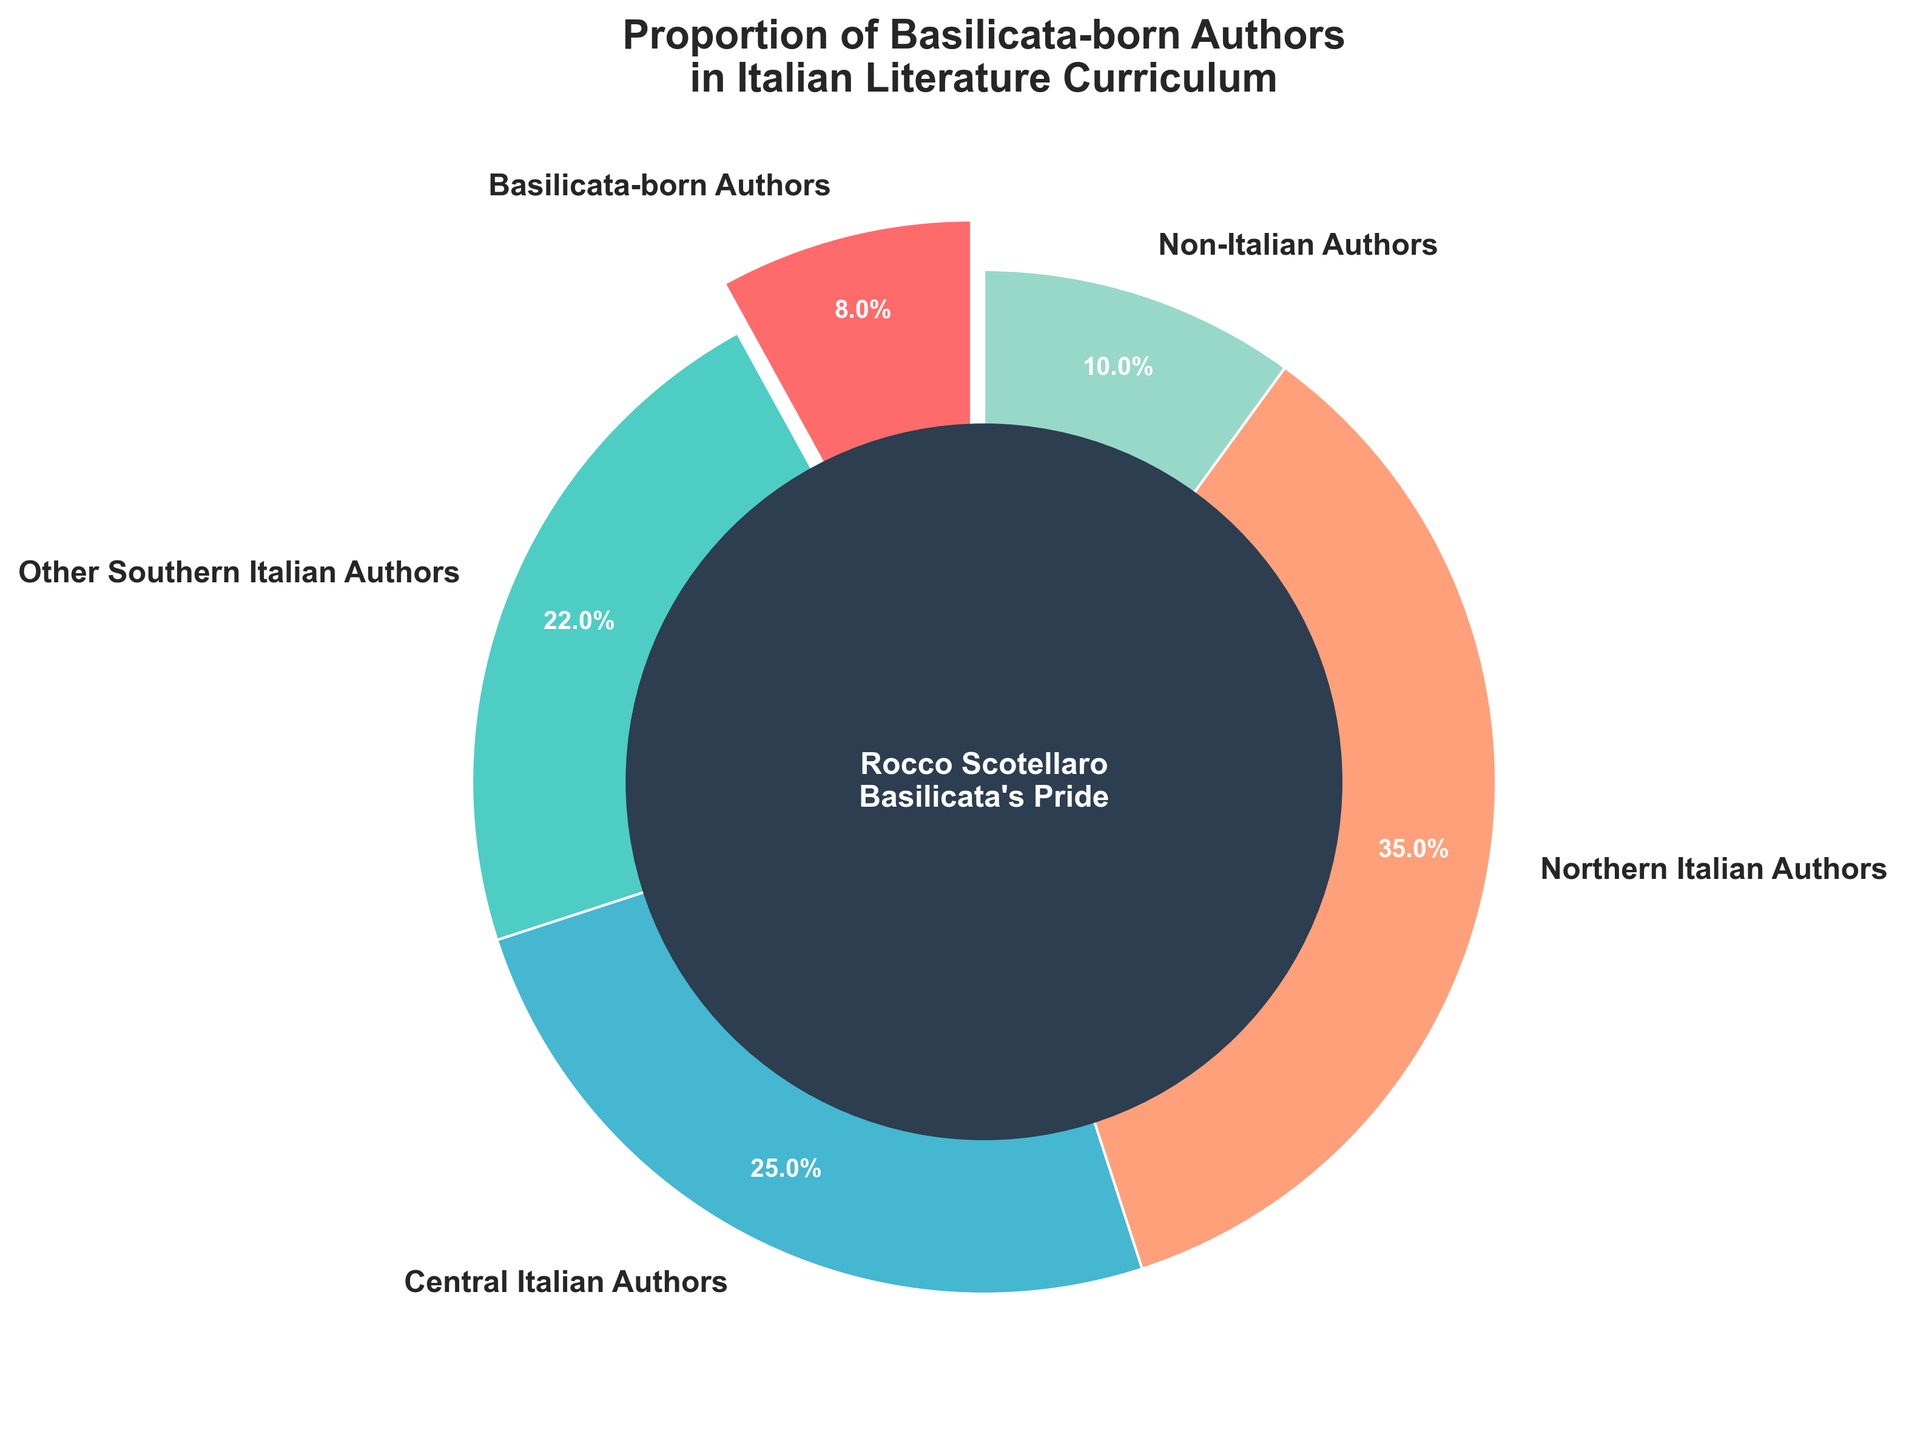How many author categories are represented in the pie chart? The pie chart has separate wedges for each author category. Counting each labeled wedge, we identify five distinct categories: Basilicata-born Authors, Other Southern Italian Authors, Central Italian Authors, Northern Italian Authors, and Non-Italian Authors.
Answer: 5 What percentage of authors are from Northern Italy? Locate the wedge labeled "Northern Italian Authors," and check its associated percentage. The pie chart shows that Northern Italian Authors represent 35% of the total.
Answer: 35% Which category has the smallest representation in the curriculum? Compare the percentages shown for each category in the pie chart. The smallest percentage is associated with Basilicata-born Authors at 8%.
Answer: Basilicata-born Authors How much larger is the percentage of Northern Italian Authors compared to Basilicata-born Authors? Subtract the percentage associated with Basilicata-born Authors from that of Northern Italian Authors, which is 35% - 8%.
Answer: 27% What is the combined percentage of Southern Italian Authors (Basilicata-born and Other Southern Italian Authors)? Add the percentages of Basilicata-born Authors (8%) and Other Southern Italian Authors (22%) together: 8% + 22%.
Answer: 30% By how much do Northern Italian Authors exceed Non-Italian Authors in percentage representation? Subtract the percentage of Non-Italian Authors from that of Northern Italian Authors: 35% - 10%.
Answer: 25% Which category occupies the center of the pie chart, and what visual feature highlights it? The center of the chart highlights Basilicata-born Authors, with a darker circle that contains the text "Rocco Scotellaro, Basilicata's Pride" to draw attention to them.
Answer: Basilicata-born Authors Does the pie chart visually prioritize any specific author category using an explosion effect? The pie chart uses an explosion effect (separating the wedge slightly from the center) for the Basilicata-born Authors wedge.
Answer: Basilicata-born Authors Which two regions together represent half of the curriculum's author proportions? Add percentages for Northern Italian Authors (35%) and Central Italian Authors (25%). Together, they represent 35% + 25% = 60%, which is more than half. Alternatively, combining Other Southern Italian Authors (22%) and Central Italian Authors (25%) gives 47%, which is less than half. Hence, Northern and Central Italian authors together exceed half.
Answer: Northern and Central Italian Authors If we consider the combined percentages of Central and Northern Italian Authors, what portion remains for all other categories? Combine the percentages for Central (25%) and Northern Italian Authors (35%) to get 60%. Subtracting this from the total (100%) gives the combined percentage for all other categories: 100% - 60%.
Answer: 40% 